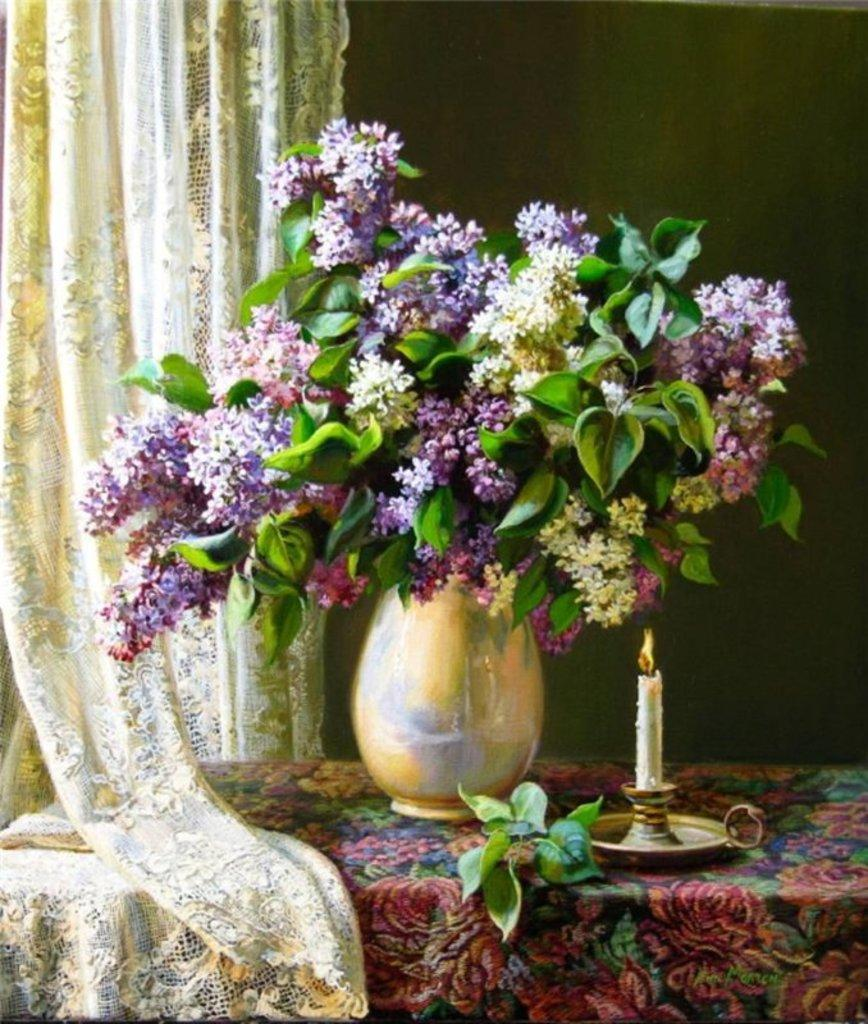What is the main object in the image? There is a table in the image. How is the table decorated? The table is covered with a colorful cloth. What can be found on top of the table? There is a flower pot on the table, and it contains different types of flowers. What color is the cloth visible in the background? There is a cream-colored cloth visible in the background. What theory is being discussed in the image? There is no discussion or theory present in the image; it features a table with a colorful cloth, a flower pot, and flowers. 